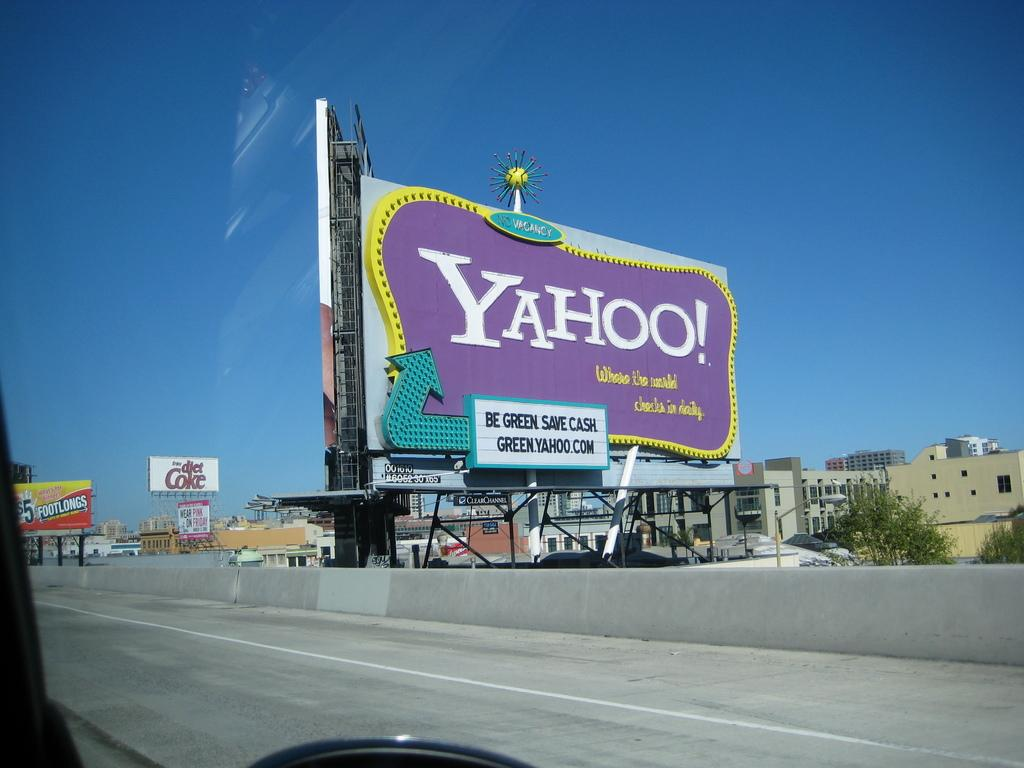Provide a one-sentence caption for the provided image. A large purple billboard advertising for Yahoo and being green. 